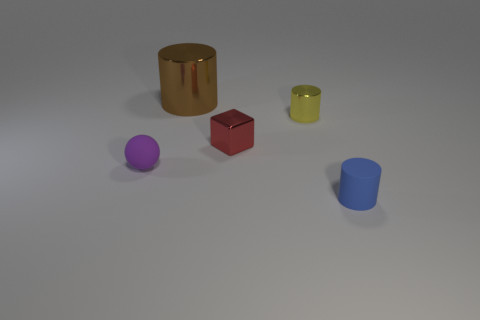Is there any other thing that is the same shape as the purple object?
Your answer should be very brief. No. What color is the other matte object that is the same shape as the large brown thing?
Your response must be concise. Blue. How many things are either large brown shiny balls or cylinders that are in front of the tiny purple thing?
Offer a terse response. 1. Is the number of yellow objects to the left of the small metal block less than the number of tiny cyan things?
Your answer should be compact. No. There is a matte object that is to the right of the small matte thing behind the thing that is in front of the small purple sphere; what is its size?
Your response must be concise. Small. What color is the metal thing that is behind the block and in front of the large object?
Offer a terse response. Yellow. How many small shiny things are there?
Provide a short and direct response. 2. Is there anything else that is the same size as the brown cylinder?
Offer a very short reply. No. Is the large brown cylinder made of the same material as the tiny red cube?
Ensure brevity in your answer.  Yes. There is a shiny thing to the left of the small red thing; is it the same size as the metallic cylinder in front of the large brown metal cylinder?
Provide a short and direct response. No. 